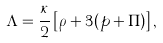Convert formula to latex. <formula><loc_0><loc_0><loc_500><loc_500>\Lambda = \frac { \kappa } { 2 } \left [ \rho + 3 ( p + \Pi ) \right ] ,</formula> 